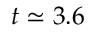<formula> <loc_0><loc_0><loc_500><loc_500>t \simeq 3 . 6</formula> 